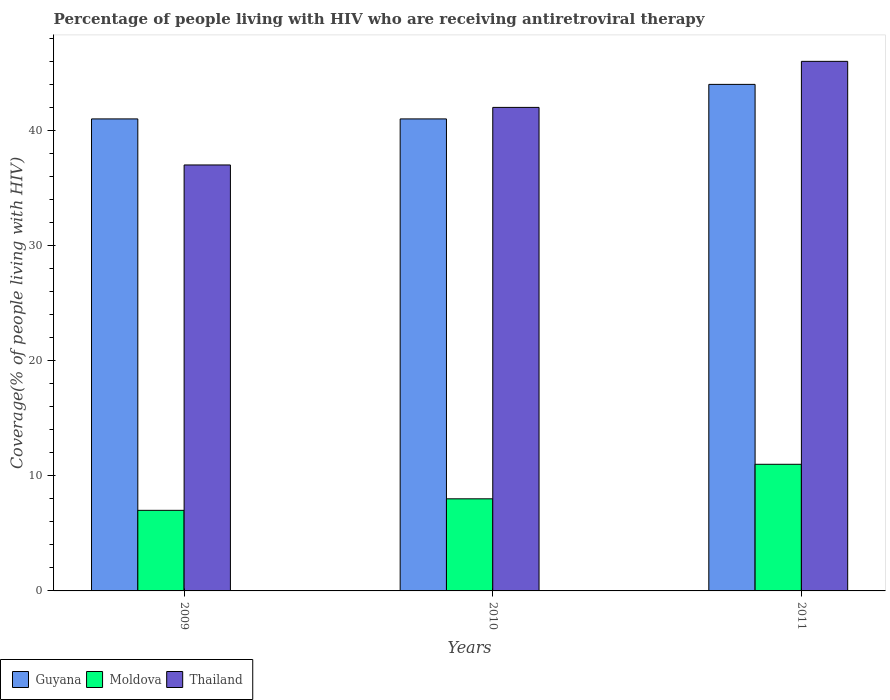How many different coloured bars are there?
Provide a short and direct response. 3. How many groups of bars are there?
Make the answer very short. 3. Are the number of bars per tick equal to the number of legend labels?
Your answer should be very brief. Yes. How many bars are there on the 3rd tick from the right?
Offer a very short reply. 3. In how many cases, is the number of bars for a given year not equal to the number of legend labels?
Your answer should be very brief. 0. What is the percentage of the HIV infected people who are receiving antiretroviral therapy in Guyana in 2011?
Provide a succinct answer. 44. Across all years, what is the maximum percentage of the HIV infected people who are receiving antiretroviral therapy in Guyana?
Keep it short and to the point. 44. Across all years, what is the minimum percentage of the HIV infected people who are receiving antiretroviral therapy in Guyana?
Make the answer very short. 41. What is the total percentage of the HIV infected people who are receiving antiretroviral therapy in Moldova in the graph?
Offer a very short reply. 26. What is the difference between the percentage of the HIV infected people who are receiving antiretroviral therapy in Thailand in 2009 and that in 2010?
Offer a terse response. -5. What is the difference between the percentage of the HIV infected people who are receiving antiretroviral therapy in Moldova in 2010 and the percentage of the HIV infected people who are receiving antiretroviral therapy in Thailand in 2009?
Keep it short and to the point. -29. What is the average percentage of the HIV infected people who are receiving antiretroviral therapy in Moldova per year?
Ensure brevity in your answer.  8.67. In the year 2009, what is the difference between the percentage of the HIV infected people who are receiving antiretroviral therapy in Moldova and percentage of the HIV infected people who are receiving antiretroviral therapy in Guyana?
Make the answer very short. -34. In how many years, is the percentage of the HIV infected people who are receiving antiretroviral therapy in Thailand greater than 34 %?
Give a very brief answer. 3. Is the percentage of the HIV infected people who are receiving antiretroviral therapy in Moldova in 2010 less than that in 2011?
Give a very brief answer. Yes. Is the difference between the percentage of the HIV infected people who are receiving antiretroviral therapy in Moldova in 2010 and 2011 greater than the difference between the percentage of the HIV infected people who are receiving antiretroviral therapy in Guyana in 2010 and 2011?
Your answer should be compact. No. What is the difference between the highest and the lowest percentage of the HIV infected people who are receiving antiretroviral therapy in Thailand?
Provide a succinct answer. 9. In how many years, is the percentage of the HIV infected people who are receiving antiretroviral therapy in Moldova greater than the average percentage of the HIV infected people who are receiving antiretroviral therapy in Moldova taken over all years?
Your answer should be very brief. 1. Is the sum of the percentage of the HIV infected people who are receiving antiretroviral therapy in Thailand in 2009 and 2010 greater than the maximum percentage of the HIV infected people who are receiving antiretroviral therapy in Guyana across all years?
Your answer should be compact. Yes. What does the 2nd bar from the left in 2010 represents?
Provide a short and direct response. Moldova. What does the 3rd bar from the right in 2011 represents?
Provide a short and direct response. Guyana. Is it the case that in every year, the sum of the percentage of the HIV infected people who are receiving antiretroviral therapy in Thailand and percentage of the HIV infected people who are receiving antiretroviral therapy in Moldova is greater than the percentage of the HIV infected people who are receiving antiretroviral therapy in Guyana?
Give a very brief answer. Yes. Are all the bars in the graph horizontal?
Your answer should be very brief. No. How many years are there in the graph?
Provide a succinct answer. 3. What is the difference between two consecutive major ticks on the Y-axis?
Your response must be concise. 10. Are the values on the major ticks of Y-axis written in scientific E-notation?
Offer a terse response. No. Does the graph contain grids?
Make the answer very short. No. Where does the legend appear in the graph?
Your answer should be very brief. Bottom left. What is the title of the graph?
Your answer should be compact. Percentage of people living with HIV who are receiving antiretroviral therapy. What is the label or title of the Y-axis?
Make the answer very short. Coverage(% of people living with HIV). What is the Coverage(% of people living with HIV) in Guyana in 2010?
Your answer should be very brief. 41. What is the Coverage(% of people living with HIV) in Moldova in 2010?
Provide a short and direct response. 8. What is the Coverage(% of people living with HIV) in Thailand in 2010?
Offer a terse response. 42. What is the Coverage(% of people living with HIV) in Guyana in 2011?
Give a very brief answer. 44. Across all years, what is the maximum Coverage(% of people living with HIV) in Guyana?
Make the answer very short. 44. What is the total Coverage(% of people living with HIV) of Guyana in the graph?
Provide a succinct answer. 126. What is the total Coverage(% of people living with HIV) of Moldova in the graph?
Provide a succinct answer. 26. What is the total Coverage(% of people living with HIV) in Thailand in the graph?
Provide a succinct answer. 125. What is the difference between the Coverage(% of people living with HIV) in Guyana in 2009 and that in 2010?
Offer a terse response. 0. What is the difference between the Coverage(% of people living with HIV) of Moldova in 2009 and that in 2010?
Ensure brevity in your answer.  -1. What is the difference between the Coverage(% of people living with HIV) in Thailand in 2009 and that in 2010?
Your answer should be very brief. -5. What is the difference between the Coverage(% of people living with HIV) of Guyana in 2009 and that in 2011?
Ensure brevity in your answer.  -3. What is the difference between the Coverage(% of people living with HIV) in Moldova in 2009 and that in 2011?
Provide a short and direct response. -4. What is the difference between the Coverage(% of people living with HIV) in Thailand in 2009 and that in 2011?
Ensure brevity in your answer.  -9. What is the difference between the Coverage(% of people living with HIV) in Guyana in 2010 and that in 2011?
Your answer should be very brief. -3. What is the difference between the Coverage(% of people living with HIV) of Thailand in 2010 and that in 2011?
Ensure brevity in your answer.  -4. What is the difference between the Coverage(% of people living with HIV) in Guyana in 2009 and the Coverage(% of people living with HIV) in Thailand in 2010?
Your answer should be very brief. -1. What is the difference between the Coverage(% of people living with HIV) of Moldova in 2009 and the Coverage(% of people living with HIV) of Thailand in 2010?
Give a very brief answer. -35. What is the difference between the Coverage(% of people living with HIV) in Moldova in 2009 and the Coverage(% of people living with HIV) in Thailand in 2011?
Your answer should be compact. -39. What is the difference between the Coverage(% of people living with HIV) in Moldova in 2010 and the Coverage(% of people living with HIV) in Thailand in 2011?
Keep it short and to the point. -38. What is the average Coverage(% of people living with HIV) in Guyana per year?
Make the answer very short. 42. What is the average Coverage(% of people living with HIV) in Moldova per year?
Ensure brevity in your answer.  8.67. What is the average Coverage(% of people living with HIV) in Thailand per year?
Provide a succinct answer. 41.67. In the year 2009, what is the difference between the Coverage(% of people living with HIV) of Guyana and Coverage(% of people living with HIV) of Moldova?
Provide a succinct answer. 34. In the year 2009, what is the difference between the Coverage(% of people living with HIV) of Guyana and Coverage(% of people living with HIV) of Thailand?
Offer a terse response. 4. In the year 2009, what is the difference between the Coverage(% of people living with HIV) in Moldova and Coverage(% of people living with HIV) in Thailand?
Ensure brevity in your answer.  -30. In the year 2010, what is the difference between the Coverage(% of people living with HIV) of Guyana and Coverage(% of people living with HIV) of Moldova?
Make the answer very short. 33. In the year 2010, what is the difference between the Coverage(% of people living with HIV) of Guyana and Coverage(% of people living with HIV) of Thailand?
Your response must be concise. -1. In the year 2010, what is the difference between the Coverage(% of people living with HIV) of Moldova and Coverage(% of people living with HIV) of Thailand?
Ensure brevity in your answer.  -34. In the year 2011, what is the difference between the Coverage(% of people living with HIV) in Guyana and Coverage(% of people living with HIV) in Moldova?
Keep it short and to the point. 33. In the year 2011, what is the difference between the Coverage(% of people living with HIV) in Moldova and Coverage(% of people living with HIV) in Thailand?
Ensure brevity in your answer.  -35. What is the ratio of the Coverage(% of people living with HIV) of Guyana in 2009 to that in 2010?
Your response must be concise. 1. What is the ratio of the Coverage(% of people living with HIV) in Moldova in 2009 to that in 2010?
Ensure brevity in your answer.  0.88. What is the ratio of the Coverage(% of people living with HIV) of Thailand in 2009 to that in 2010?
Your response must be concise. 0.88. What is the ratio of the Coverage(% of people living with HIV) of Guyana in 2009 to that in 2011?
Offer a very short reply. 0.93. What is the ratio of the Coverage(% of people living with HIV) in Moldova in 2009 to that in 2011?
Your answer should be compact. 0.64. What is the ratio of the Coverage(% of people living with HIV) in Thailand in 2009 to that in 2011?
Provide a succinct answer. 0.8. What is the ratio of the Coverage(% of people living with HIV) in Guyana in 2010 to that in 2011?
Your answer should be compact. 0.93. What is the ratio of the Coverage(% of people living with HIV) in Moldova in 2010 to that in 2011?
Make the answer very short. 0.73. What is the ratio of the Coverage(% of people living with HIV) in Thailand in 2010 to that in 2011?
Offer a very short reply. 0.91. What is the difference between the highest and the second highest Coverage(% of people living with HIV) in Guyana?
Your answer should be compact. 3. What is the difference between the highest and the second highest Coverage(% of people living with HIV) of Moldova?
Give a very brief answer. 3. What is the difference between the highest and the second highest Coverage(% of people living with HIV) in Thailand?
Your answer should be very brief. 4. What is the difference between the highest and the lowest Coverage(% of people living with HIV) of Guyana?
Your answer should be compact. 3. What is the difference between the highest and the lowest Coverage(% of people living with HIV) in Moldova?
Ensure brevity in your answer.  4. What is the difference between the highest and the lowest Coverage(% of people living with HIV) of Thailand?
Offer a terse response. 9. 